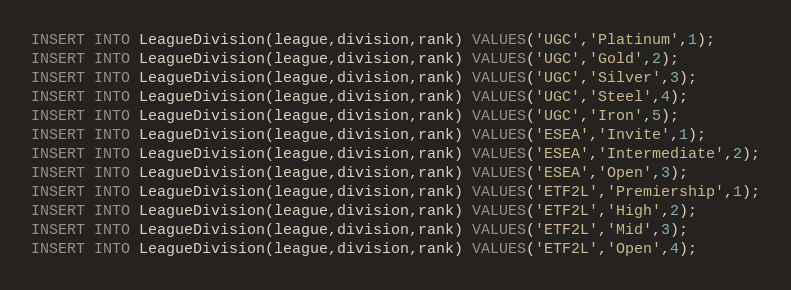<code> <loc_0><loc_0><loc_500><loc_500><_SQL_>INSERT INTO LeagueDivision(league,division,rank) VALUES('UGC','Platinum',1);
INSERT INTO LeagueDivision(league,division,rank) VALUES('UGC','Gold',2);
INSERT INTO LeagueDivision(league,division,rank) VALUES('UGC','Silver',3);
INSERT INTO LeagueDivision(league,division,rank) VALUES('UGC','Steel',4);
INSERT INTO LeagueDivision(league,division,rank) VALUES('UGC','Iron',5);
INSERT INTO LeagueDivision(league,division,rank) VALUES('ESEA','Invite',1);
INSERT INTO LeagueDivision(league,division,rank) VALUES('ESEA','Intermediate',2);
INSERT INTO LeagueDivision(league,division,rank) VALUES('ESEA','Open',3);
INSERT INTO LeagueDivision(league,division,rank) VALUES('ETF2L','Premiership',1);
INSERT INTO LeagueDivision(league,division,rank) VALUES('ETF2L','High',2);
INSERT INTO LeagueDivision(league,division,rank) VALUES('ETF2L','Mid',3);
INSERT INTO LeagueDivision(league,division,rank) VALUES('ETF2L','Open',4);
</code> 